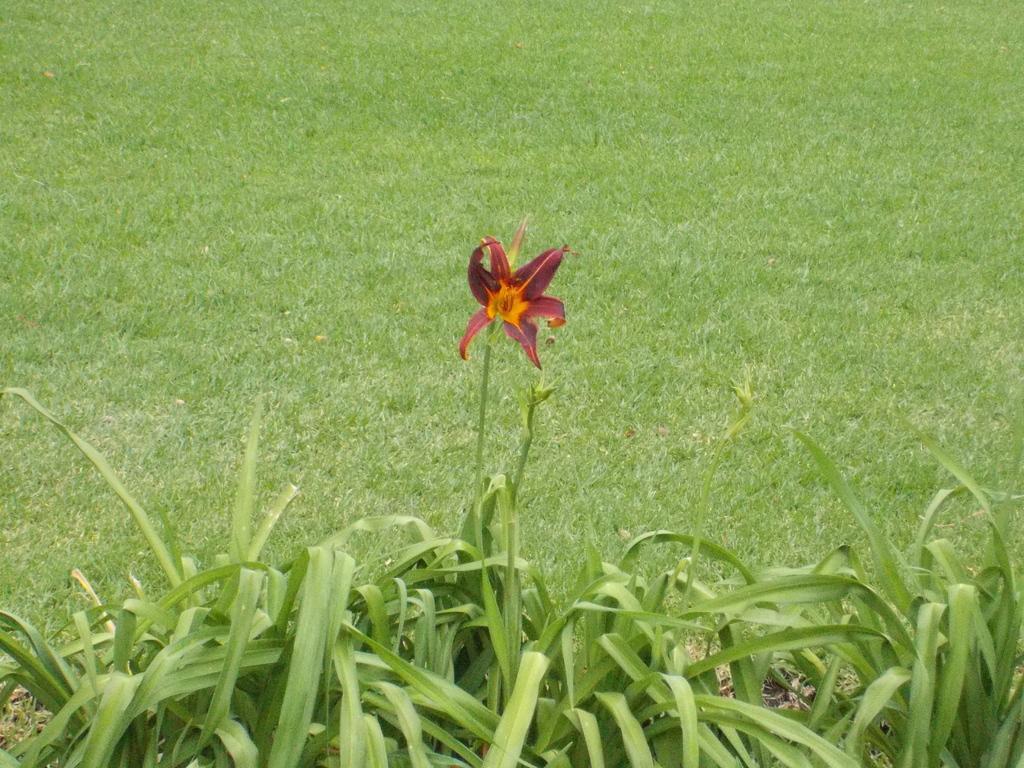How would you summarize this image in a sentence or two? In this picture I can see the plants in front and I see a flower in the centre. In the background I see the green grass. 